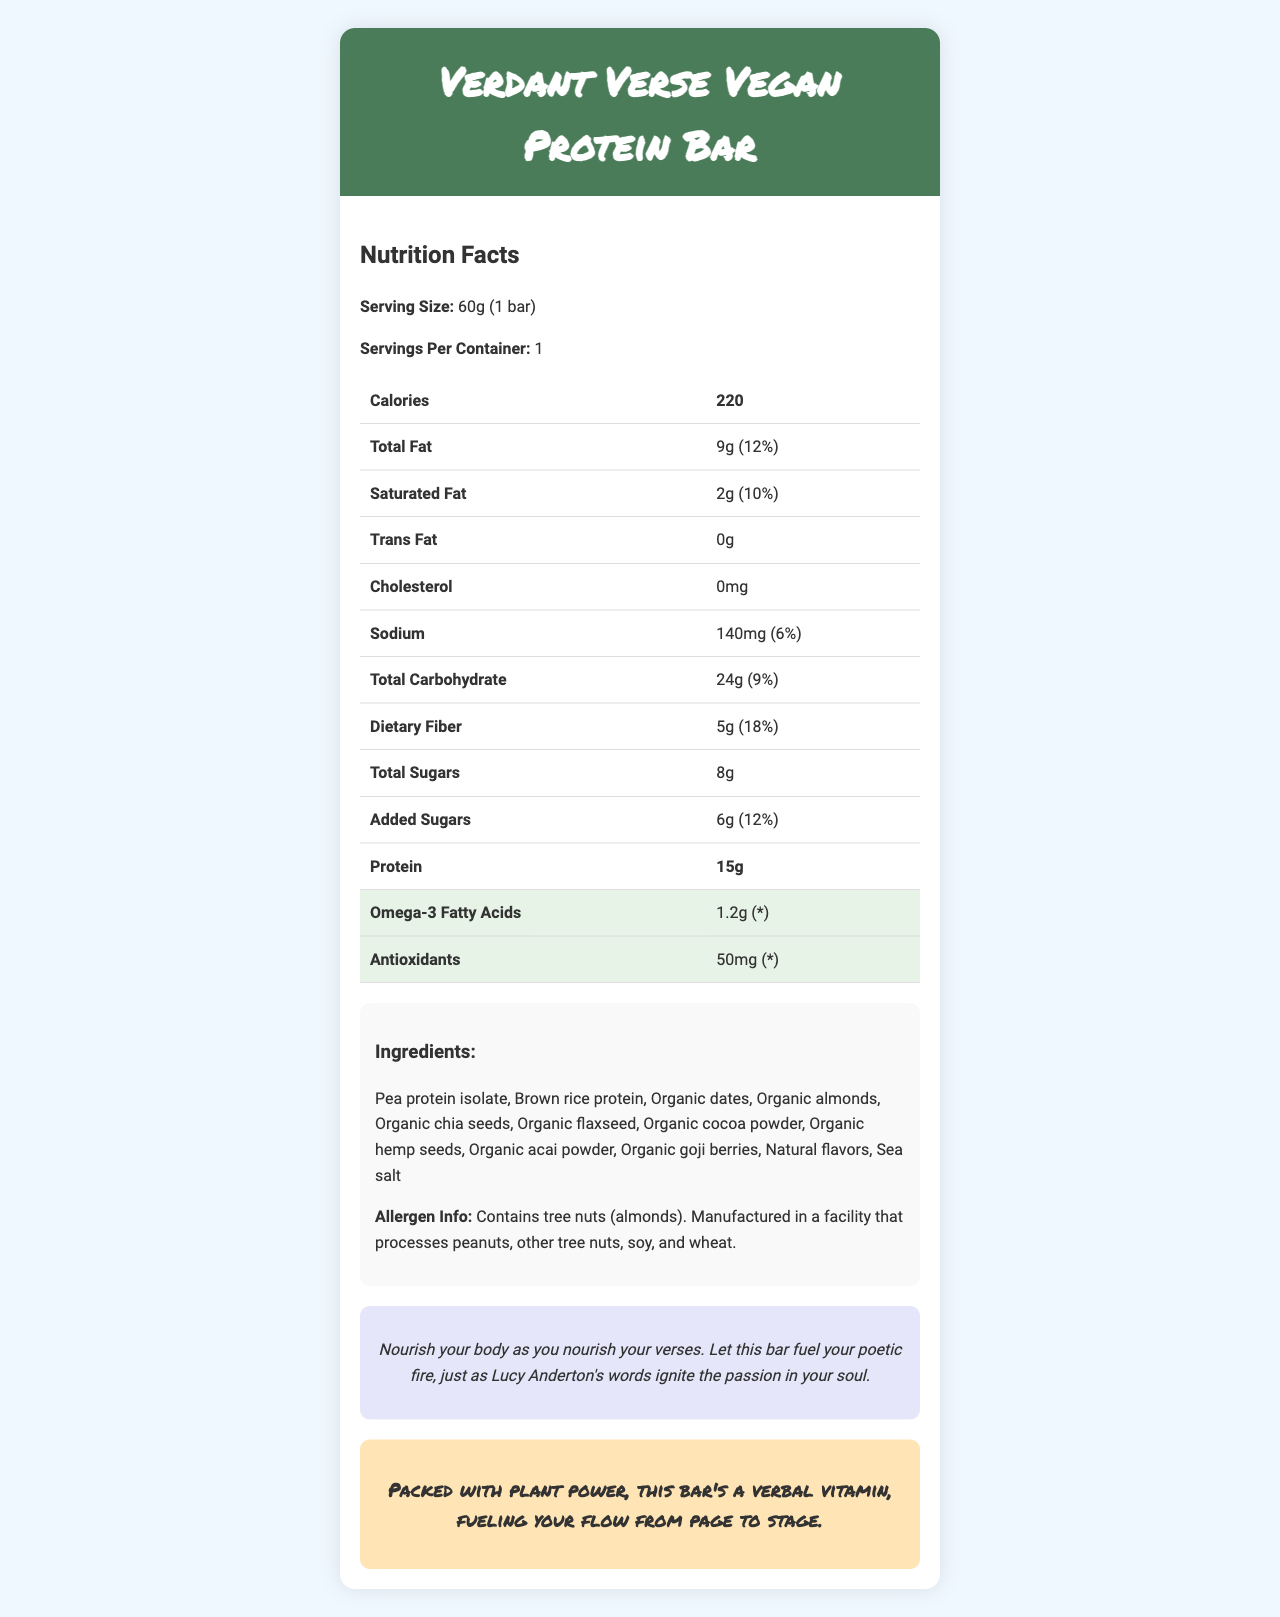what is the serving size of the Verdant Verse Vegan Protein Bar? The serving size is directly listed under the "Serving Size" section at the top of the document.
Answer: 60g (1 bar) how many calories are in one serving of the Verdant Verse Vegan Protein Bar? The number of calories per serving is indicated in the "Calories" row of the nutrition facts table.
Answer: 220 what is the amount of total fat per serving? The amount of total fat per serving is listed in the "Total Fat" row of the nutrition facts table.
Answer: 9g how much protein does one bar contain? The amount of protein per bar is given in the "Protein" row of the nutrition facts table.
Answer: 15g what are the main ingredients of the Verdant Verse Vegan Protein Bar? The ingredients are listed in the ingredients section.
Answer: Pea protein isolate, Brown rice protein, Organic dates, Organic almonds, Organic chia seeds, Organic flaxseed, Organic cocoa powder, Organic hemp seeds, Organic acai powder, Organic goji berries, Natural flavors, Sea salt what percentage of the daily value for iron does one bar provide? The percentage of daily value for iron is listed in the "Iron" row of the nutrition facts table.
Answer: 15% which of the following does the Verdant Verse Vegan Protein Bar contain? A. Lactose B. Soy C. Tree nuts The allergen info states that the bar contains tree nuts (almonds) but does not mention lactose or soy.
Answer: C how many mg of potassium are in one bar? The milligrams of potassium per bar are listed in the "Potassium" row of the nutrition facts table.
Answer: 200mg which ingredient is NOT part of the Verdant Verse Vegan Protein Bar? A. Organic flaxseed B. Organic peanuts C. Organic hemp seeds D. Organic cocoa powder Organic peanuts are not listed in the ingredients section, while the other ingredients are.
Answer: B does the Verdant Verse Vegan Protein Bar contain added sugars? The "Added Sugars" row in the nutrition facts table shows 6g of added sugars.
Answer: Yes how does the Verdant Verse Vegan Protein Bar support antioxidant intake? The table highlights that it contains 50mg of antioxidants, enhancing its nutritional profile with antioxidants.
Answer: It provides 50mg of antioxidants summarize the main idea of this document. The document provides comprehensive nutrition information, ingredients, and allergen details. It also includes inspirational and slam-ready quotes to motivate the reader.
Answer: The Verdant Verse Vegan Protein Bar provides a detailed nutrition facts label with key components including calories, fats, carbohydrates, protein, antioxidants, and omega-3s. It highlights its plant-based ingredients and includes poetically inspired quotes. can the exact manufacturing location be determined from the document? The document mentions the facility processes other allergens, but it does not provide the specific location of the manufacturing facility.
Answer: No 